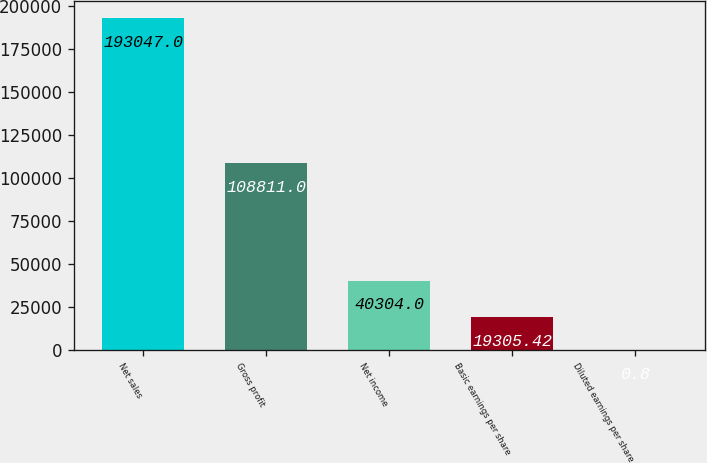<chart> <loc_0><loc_0><loc_500><loc_500><bar_chart><fcel>Net sales<fcel>Gross profit<fcel>Net income<fcel>Basic earnings per share<fcel>Diluted earnings per share<nl><fcel>193047<fcel>108811<fcel>40304<fcel>19305.4<fcel>0.8<nl></chart> 